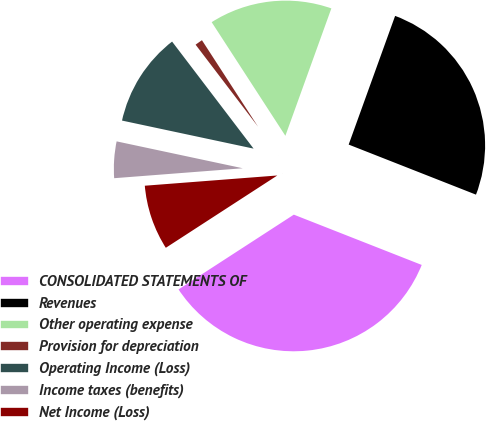Convert chart to OTSL. <chart><loc_0><loc_0><loc_500><loc_500><pie_chart><fcel>CONSOLIDATED STATEMENTS OF<fcel>Revenues<fcel>Other operating expense<fcel>Provision for depreciation<fcel>Operating Income (Loss)<fcel>Income taxes (benefits)<fcel>Net Income (Loss)<nl><fcel>34.88%<fcel>25.45%<fcel>14.67%<fcel>1.2%<fcel>11.3%<fcel>4.57%<fcel>7.93%<nl></chart> 